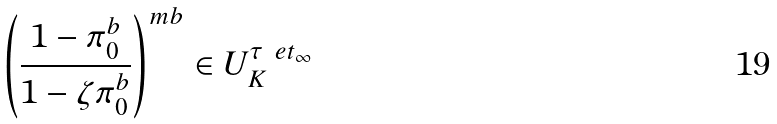Convert formula to latex. <formula><loc_0><loc_0><loc_500><loc_500>\left ( \frac { 1 - \pi _ { 0 } ^ { b } } { 1 - \zeta \pi _ { 0 } ^ { b } } \right ) ^ { m b } \in U ^ { \tau ^ { \ } e t _ { \infty } } _ { K }</formula> 